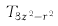Convert formula to latex. <formula><loc_0><loc_0><loc_500><loc_500>T _ { 3 z ^ { 2 } - r ^ { 2 } }</formula> 